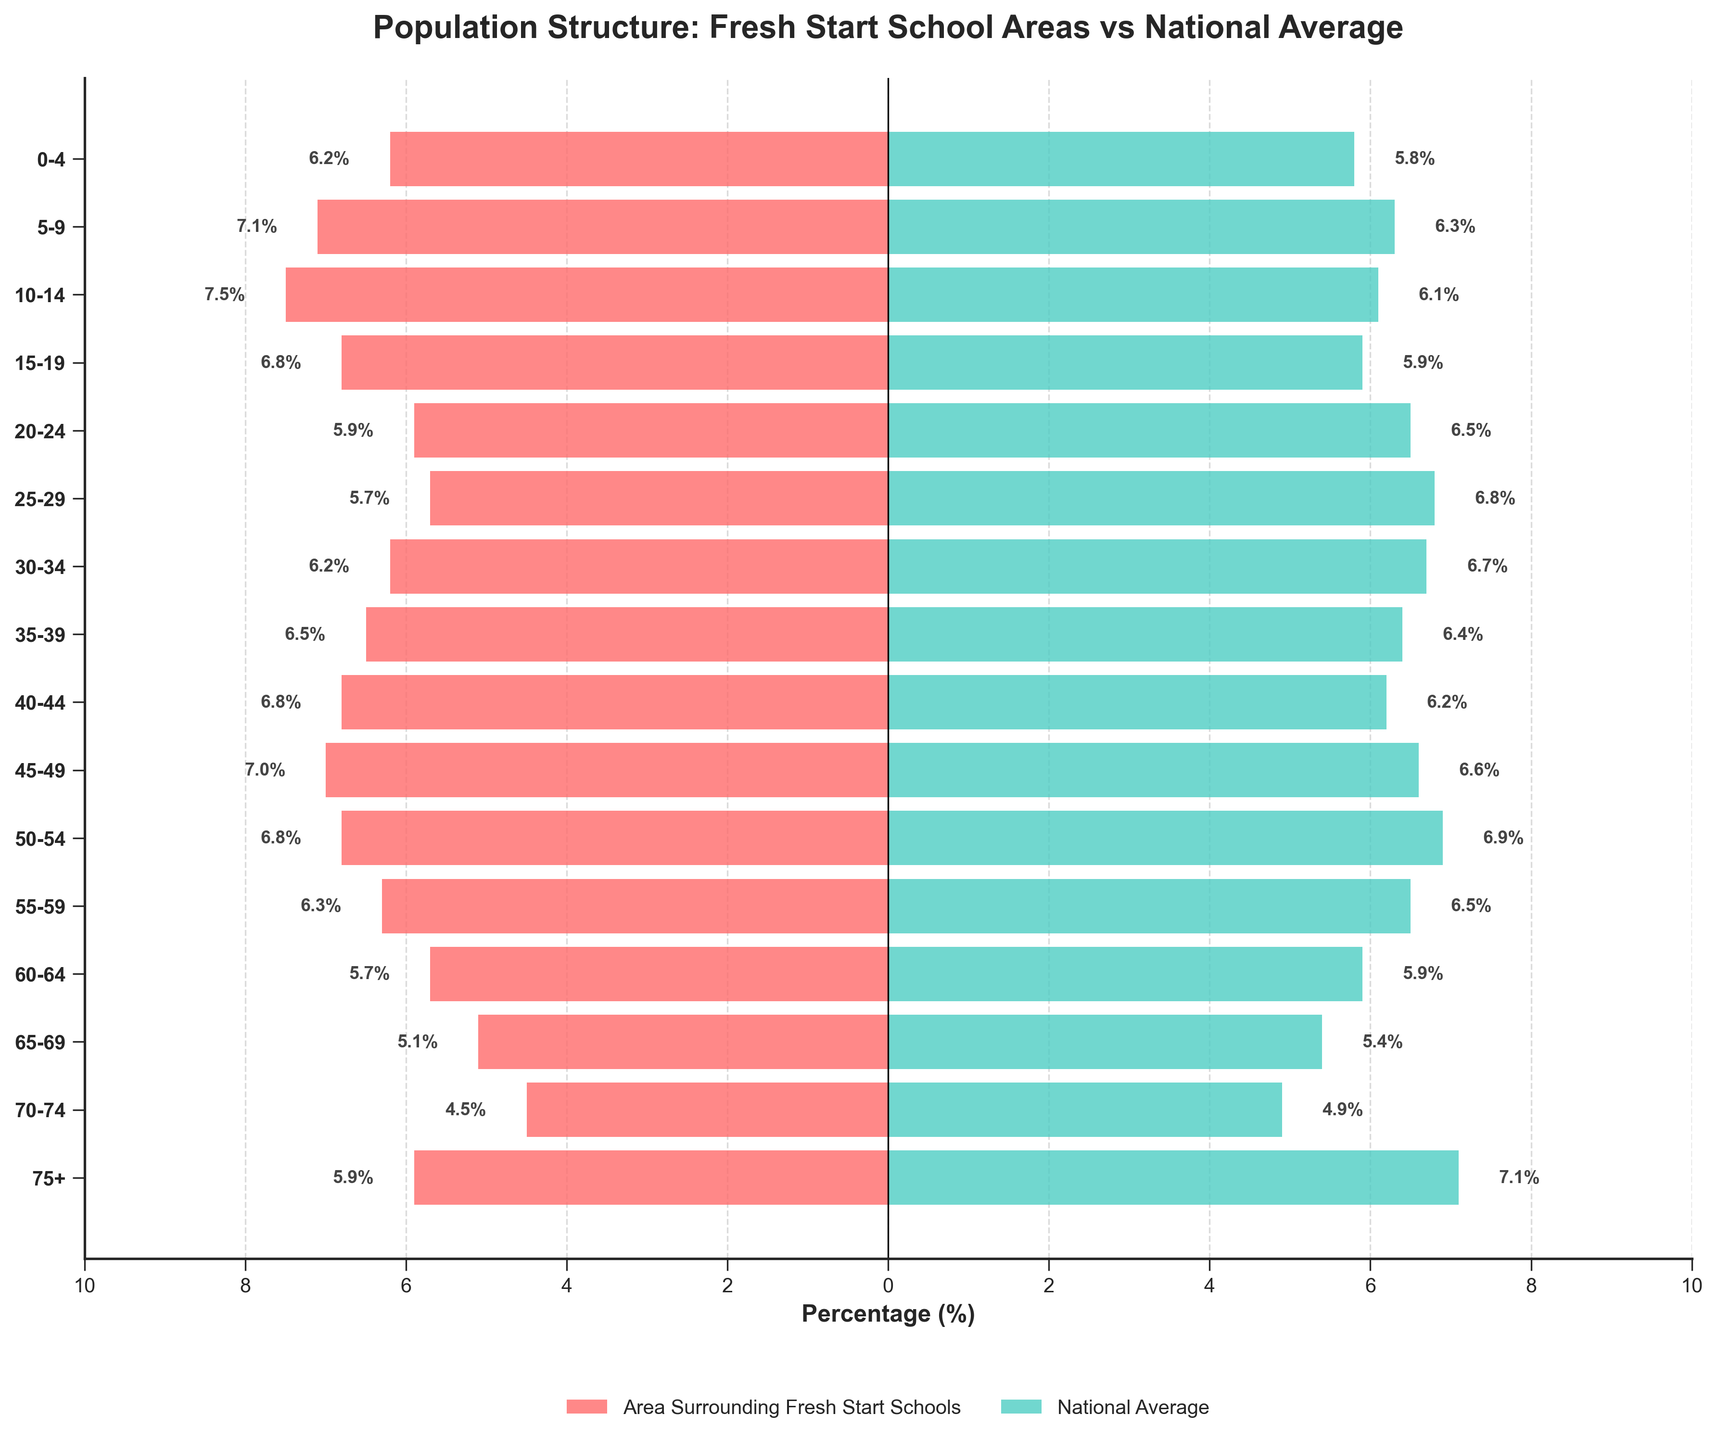What's the title of the figure? The title can be found at the top of the figure in bold text. It reads as "Population Structure: Fresh Start School Areas vs National Average".
Answer: Population Structure: Fresh Start School Areas vs National Average Which age group has the highest percentage in the areas surrounding Fresh Start Schools? By looking at the red bars on the left side of the pyramid, the longest bar represents the 10-14 age group with a percentage of 7.5%.
Answer: 10-14 How many age groups have a higher percentage in the areas surrounding Fresh Start Schools compared to the national average? We need to compare each pair of values from the left (area surrounding Fresh Start Schools) to the right (national average). There are 8 age groups where the left value is higher: 0-4, 5-9, 10-14, 15-19, 35-39, 40-44, 45-49, and 55-59.
Answer: 8 Which age group has the largest difference in percentage between the areas surrounding Fresh Start Schools and the national average? By calculating the absolute difference for each age group: 
0-4: 0.4, 5-9: 0.8, 10-14: 1.4, 15-19: 0.9, 20-24: 0.6, 25-29: 1.1, 30-34: 0.5, 35-39: 0.1, 40-44: 0.6, 45-49: 0.4, 50-54: 0.1, 55-59: 0.2, 60-64: 0.2, 65-69: 0.3, 70-74: 0.4, 75+: 1.2. The 10-14 age group has the largest difference of 1.4%.
Answer: 10-14 What is the total percentage of the population under 20 years old in the areas surrounding Fresh Start Schools? Sum up the percentages of the 0-4, 5-9, 10-14, and 15-19 age groups: 6.2 + 7.1 + 7.5 + 6.8 = 27.6%.
Answer: 27.6% Which age group shows a reverse trend, being higher in the national average compared to the areas surrounding Fresh Start Schools for the older population (60+ years)? Look at the age groups 60-64, 65-69, 70-74, and 75+. All four age groups show this trend.
Answer: 60-64, 65-69, 70-74, 75+ What percentage of the 75+ age group does the national average exceed that of the areas surrounding Fresh Start Schools? The national average for 75+ is 7.1% and for areas surrounding Fresh Start Schools, it is 5.9%. The difference is 7.1% - 5.9% = 1.2%.
Answer: 1.2% For which age group is the population percentage nearly equal between the areas surrounding Fresh Start Schools and the national average? Comparing the bars, the most similar percentages are in the 35-39 and 50-54 age groups. Both have almost the same lengths.
Answer: 35-39 and 50-54 Which age group is the smallest in percentage in areas surrounding Fresh Start Schools? By looking at the red bars on the left side, the smallest bar represents the 70-74 age group with a percentage of 4.5%.
Answer: 70-74 